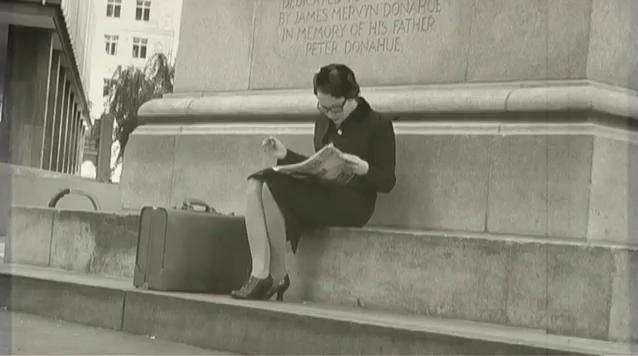Where is the luggage?
Quick response, please. Next to woman. What is sitting on the ground next to the lady?
Be succinct. Suitcase. What is the woman doing?
Give a very brief answer. Reading. 